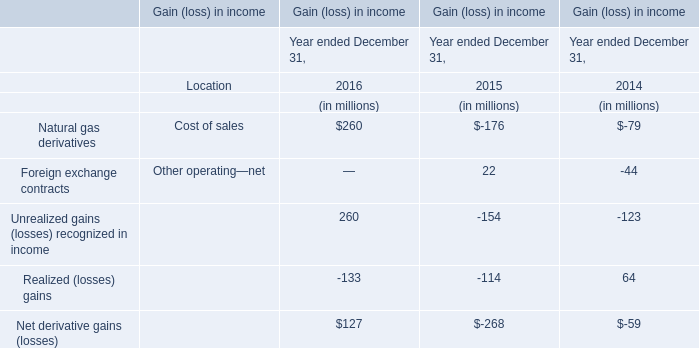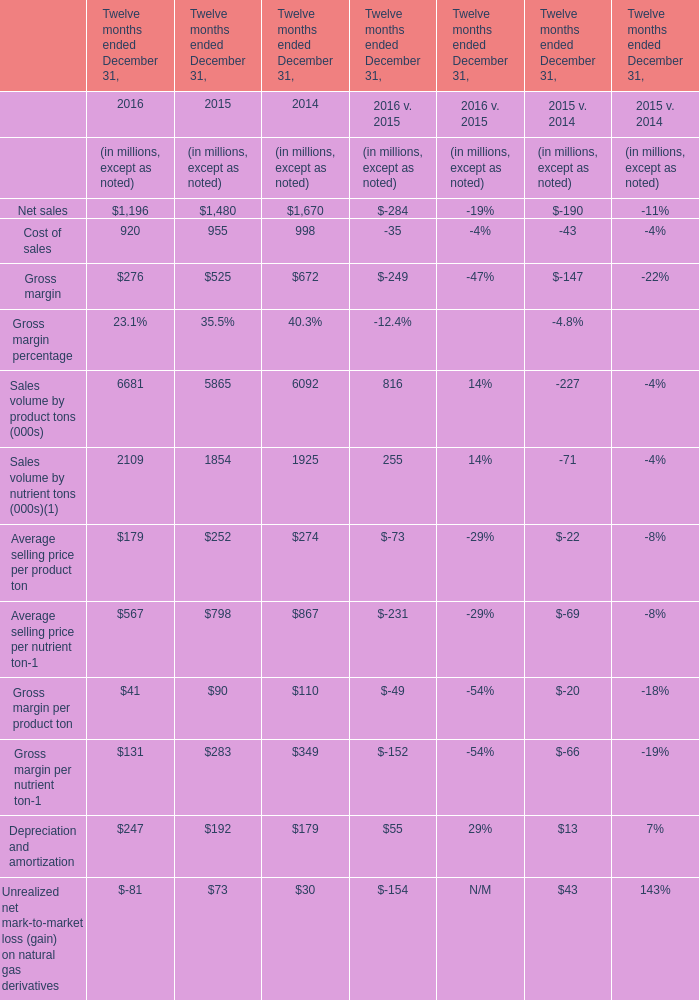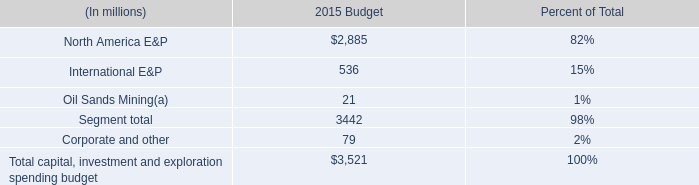what percentage of the board of directors approved budget was capital expenditures? 
Computations: (3.4 / 3.5)
Answer: 0.97143. 